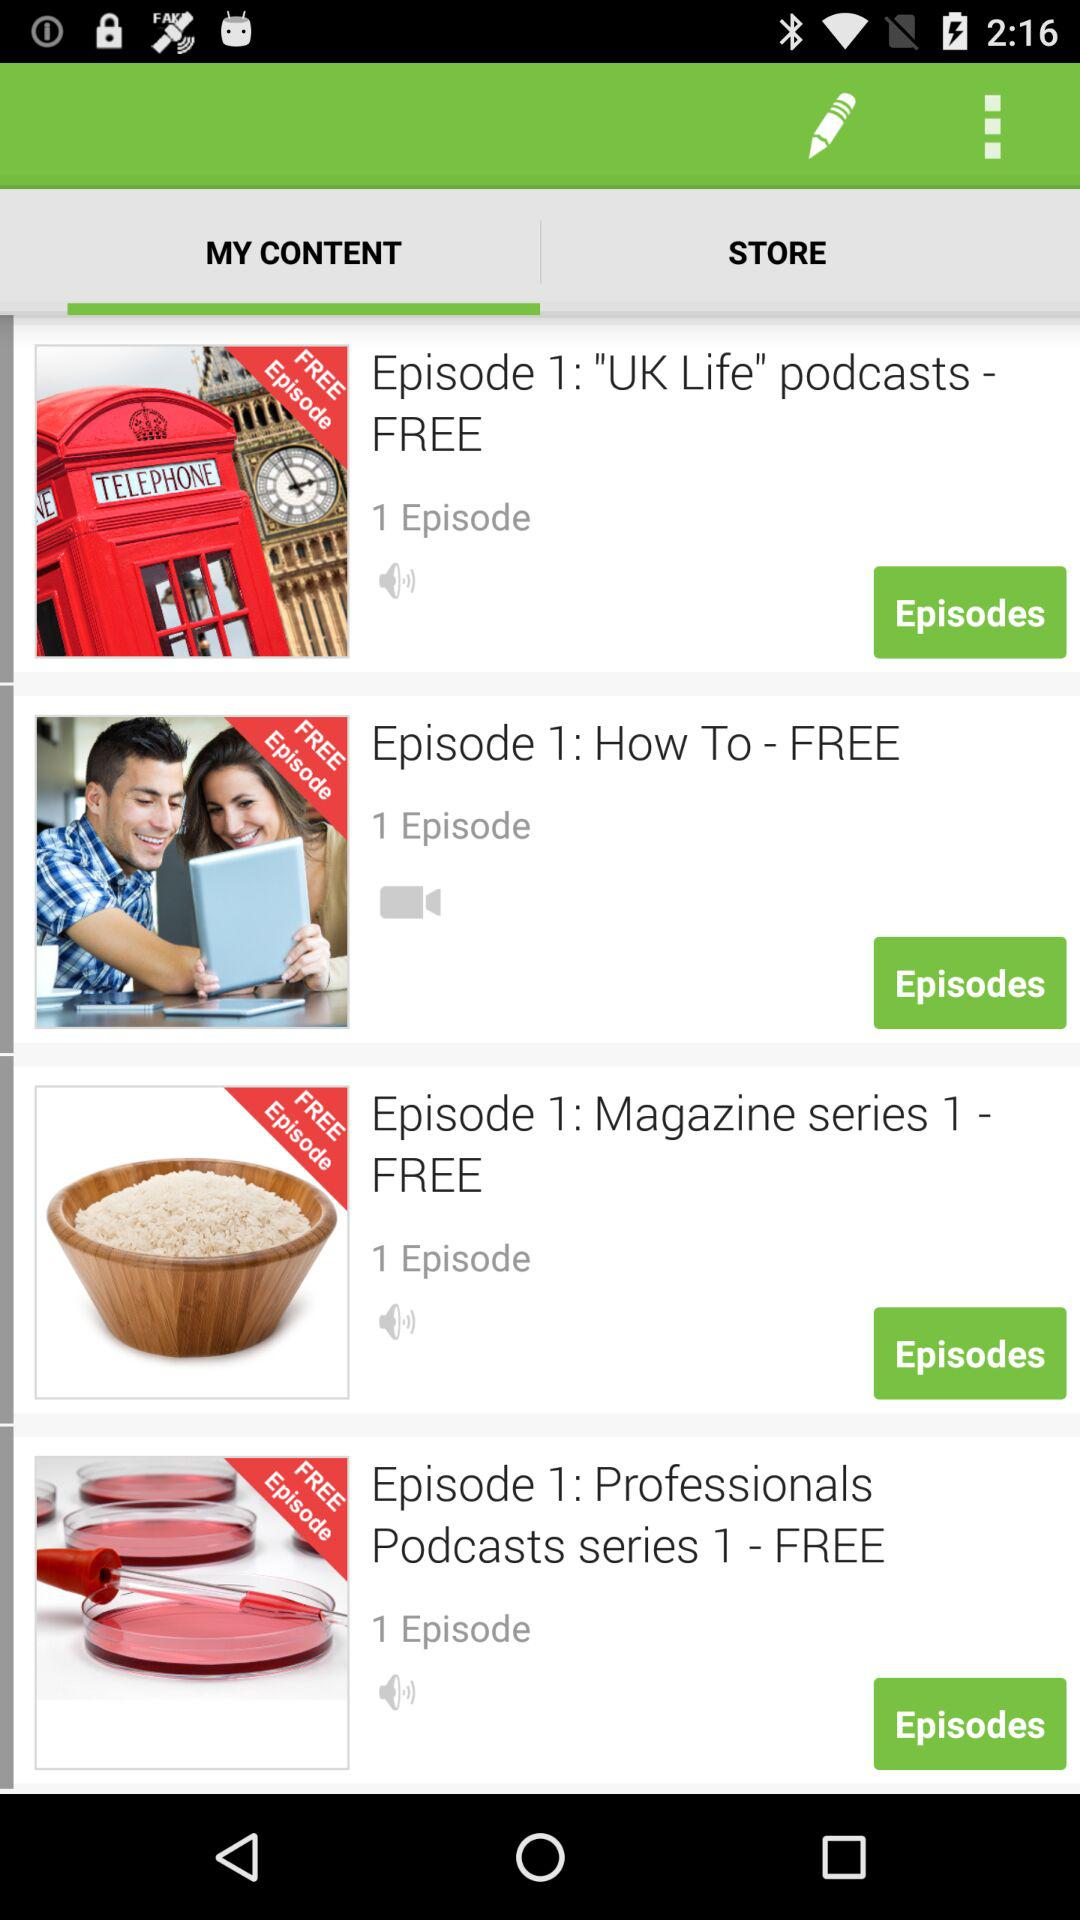What is the number of episodes in "Episode 1: How To - FREE"? The number of episodes in "Episode 1: How To - FREE" is 1. 